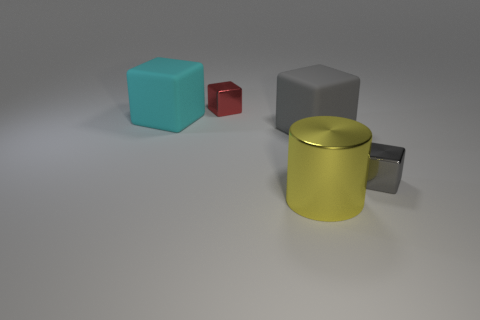Subtract all red metal blocks. How many blocks are left? 3 Add 2 gray metallic objects. How many objects exist? 7 Subtract all red cubes. How many cubes are left? 3 Subtract all big gray objects. Subtract all big yellow things. How many objects are left? 3 Add 5 matte blocks. How many matte blocks are left? 7 Add 1 red objects. How many red objects exist? 2 Subtract 0 purple cubes. How many objects are left? 5 Subtract all cylinders. How many objects are left? 4 Subtract 1 blocks. How many blocks are left? 3 Subtract all gray cubes. Subtract all brown cylinders. How many cubes are left? 2 